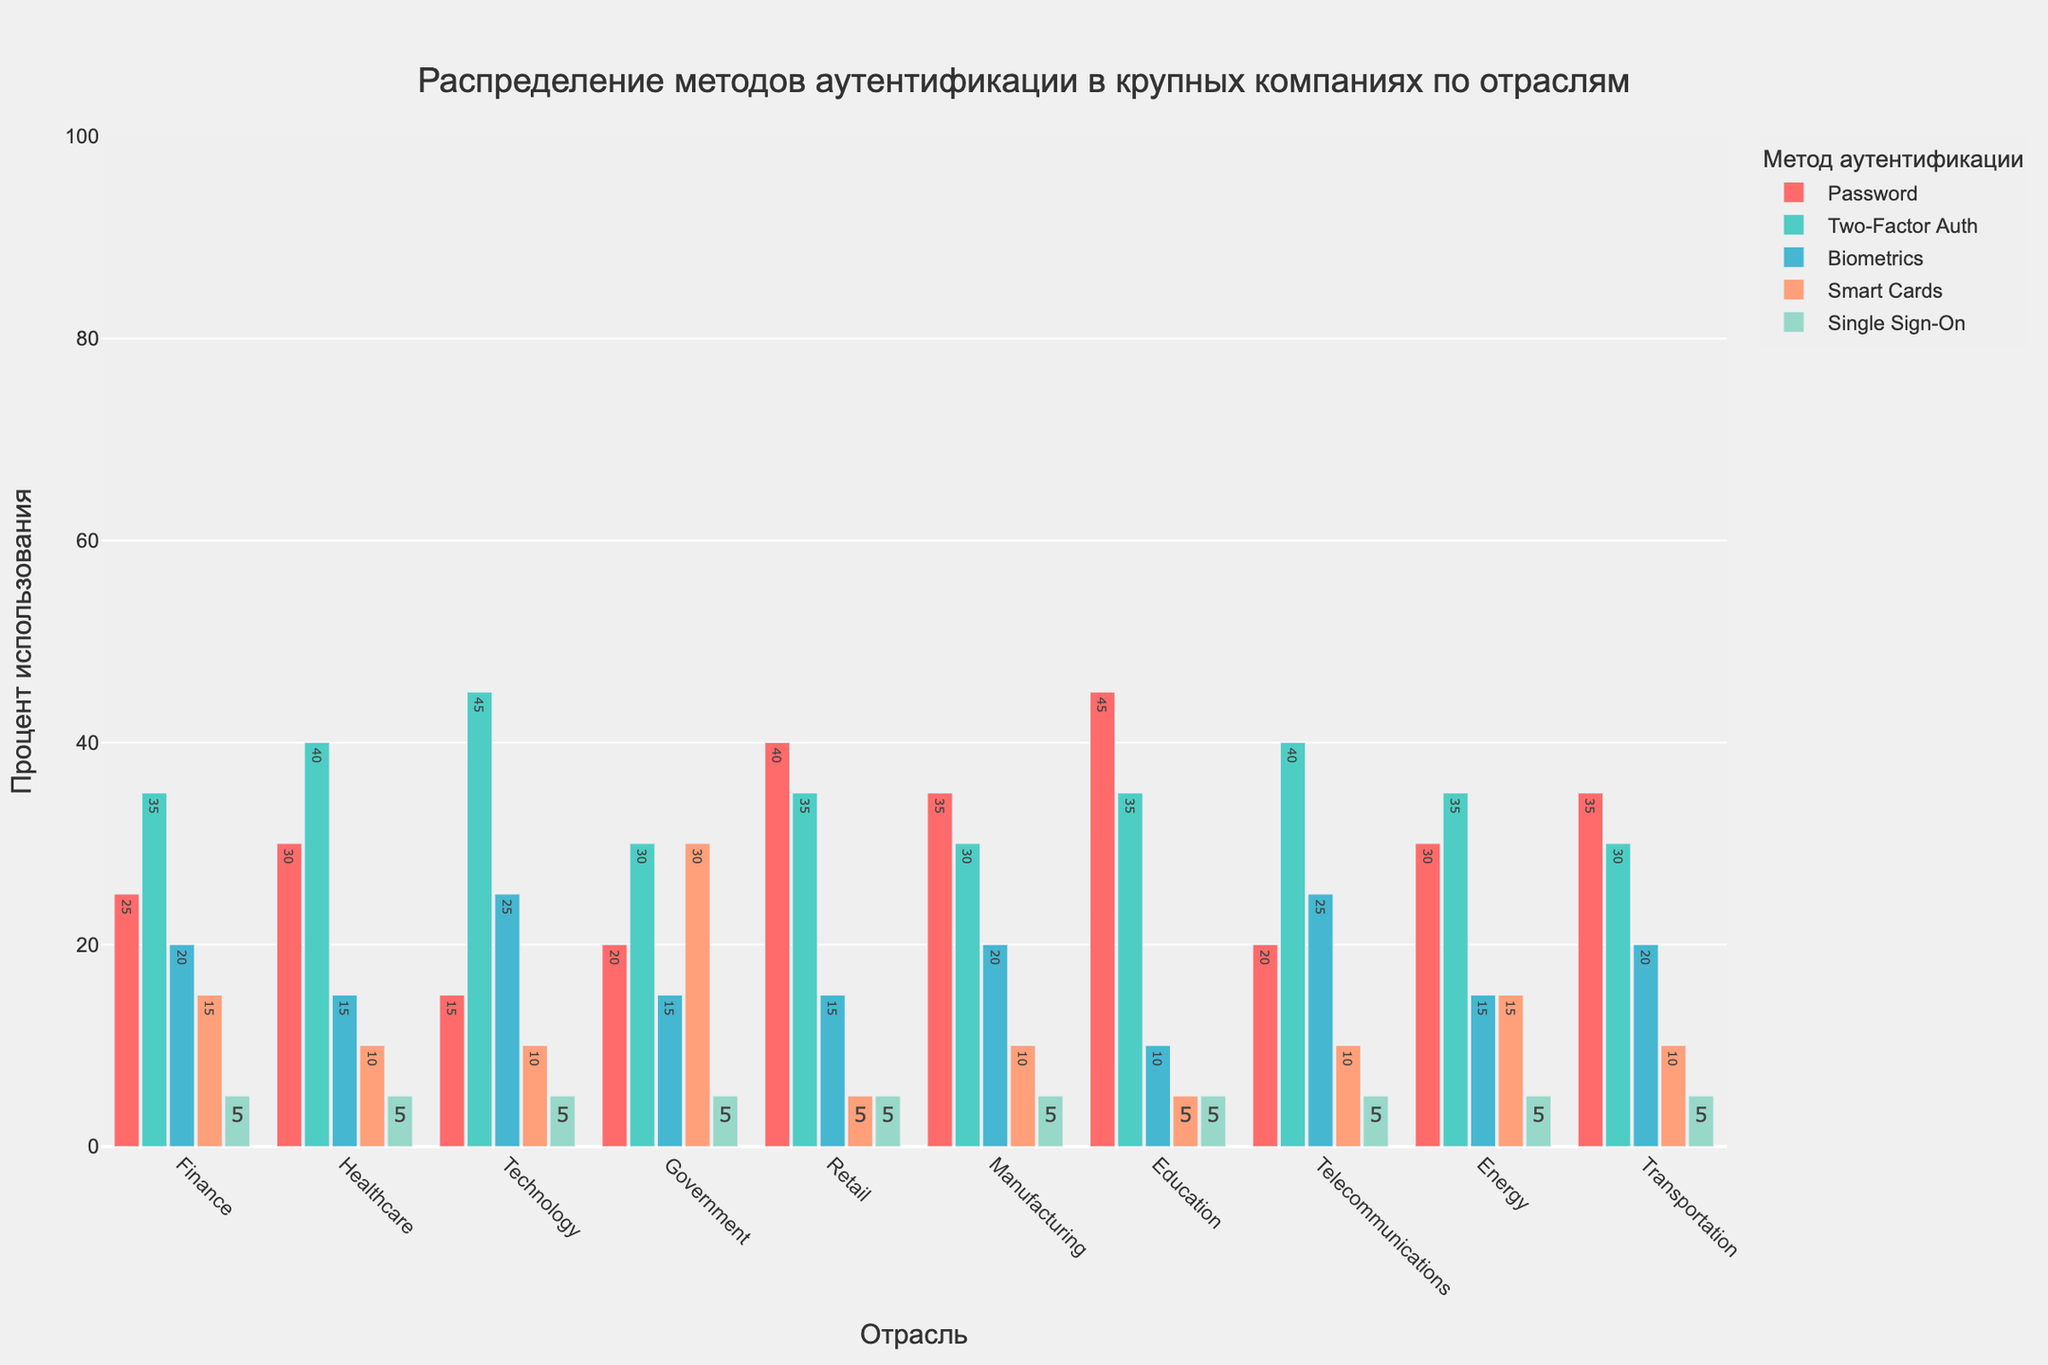как какая
Answer: краткий ответ Which industry uses biometrics at the highest percentage? We look at the "Biometrics" data across all industries and identify that the "Technology" and "Telecommunications" industries both have the highest value, which is 25%.
Answer: Technology and Telecommunications What is the average percentage use of Smart Cards across all industries? Sum up the percentages for Smart Cards across all industries (15+10+10+30+5+10+5+10+15+10) and divide by the number of industries (10). The calculation is (120/10 = 12).
Answer: 12 How does the use of Two-Factor Authentication in the Technology sector compare to the Finance sector? We compare the percentages in the "Two-Factor Auth" column for both industries. Technology has 45% and Finance has 35%. Technology uses Two-Factor Authentication at a higher percentage.
Answer: Technology uses more What is the total percentage of Single Sign-On use across all industries? Sum up the percentages for Single Sign-On across all industries: (5+5+5+5+5+5+5+5+5+5). The calculation is (50).
Answer: 50 Which industry uses passwords the least? We look at the "Passwords" column and find the minimum value, which is for the Technology industry with 15%.
Answer: Technology Given the data, is there any industry where the use of Smart Cards exceeds the use of Biometrics? Compare the values for Smart Cards and Biometrics for each industry. Only the Government industry has a higher value of Smart Cards (30%) compared to Biometrics (15%).
Answer: Government Compare the use of Two-Factor Authentication and Biometrics in the Healthcare industry. Which is higher and by how much? In Healthcare, Two-Factor Authentication is 40% while Biometrics is 15%. The difference is (40-15 = 25).
Answer: Two-Factor Authentication by 25% What is the range of password usage across the industries? Identify the maximum (45% in Education) and minimum (15% in Technology) values for passwords and calculate the range (45-15=30).
Answer: 30 Which method of authentication is the least used across all industries? Sum the values for each authentication method across all industries and find the smallest sum. Single Sign-On with a sum of 50 is the least used method.
Answer: Single Sign-On 